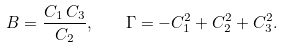<formula> <loc_0><loc_0><loc_500><loc_500>B = \frac { C _ { 1 } \, C _ { 3 } } { C _ { 2 } } , \quad \Gamma = - C _ { 1 } ^ { 2 } + C _ { 2 } ^ { 2 } + C _ { 3 } ^ { 2 } .</formula> 